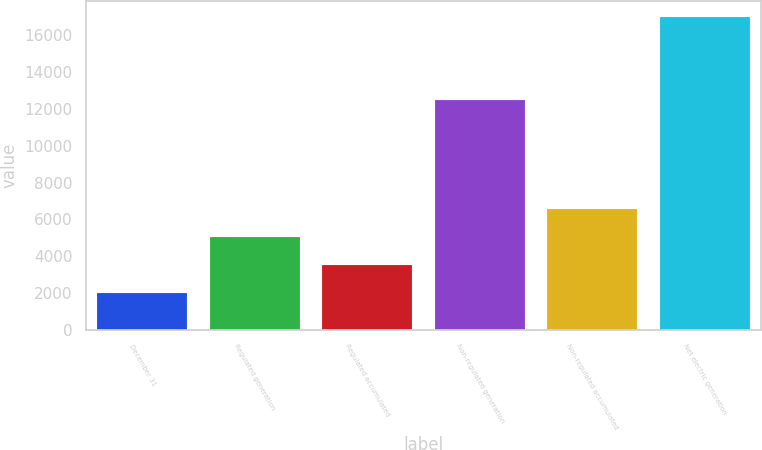Convert chart to OTSL. <chart><loc_0><loc_0><loc_500><loc_500><bar_chart><fcel>December 31<fcel>Regulated generation<fcel>Regulated accumulated<fcel>Non-regulated generation<fcel>Non-regulated accumulated<fcel>Net electric generation<nl><fcel>2016<fcel>5032<fcel>3524<fcel>12476<fcel>6540<fcel>16992<nl></chart> 